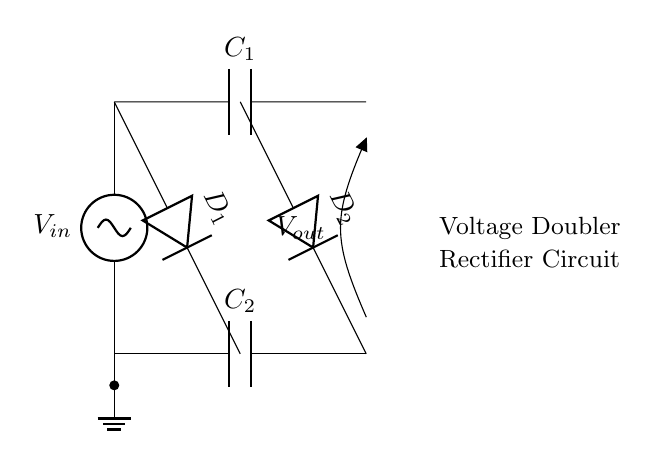What is the input voltage labeled in the circuit? The input voltage is denoted as V in the circuit diagram, positioned at the top left.
Answer: V in What components are used in this rectifier circuit? The circuit includes two capacitors, C1 and C2, and two diodes, D1 and D2. These components are essential for the operation of the voltage doubler.
Answer: C1, C2, D1, D2 How many output terminals are shown in the diagram? There is one output terminal indicated in the circuit diagram, where the output voltage V out is labeled.
Answer: One What is the purpose of the capacitors in this circuit? The capacitors, C1 and C2, store and release energy, helping to smooth the output voltage and boost the low-voltage signals in the embedded system.
Answer: Energy storage What is the relationship between the diodes and the capacitors in this circuit? The diodes D1 and D2 allow current to flow in one direction, charging the capacitors while preventing discharge back into the input, essential for the voltage doubling operation.
Answer: Prevent discharge What is the expected output voltage from this voltage doubler circuit when V in is 5V? The output voltage V out is expected to be approximately twice the input voltage, assuming ideal conditions and no losses, thus V out would be 10V.
Answer: 10V 